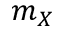<formula> <loc_0><loc_0><loc_500><loc_500>m _ { X }</formula> 